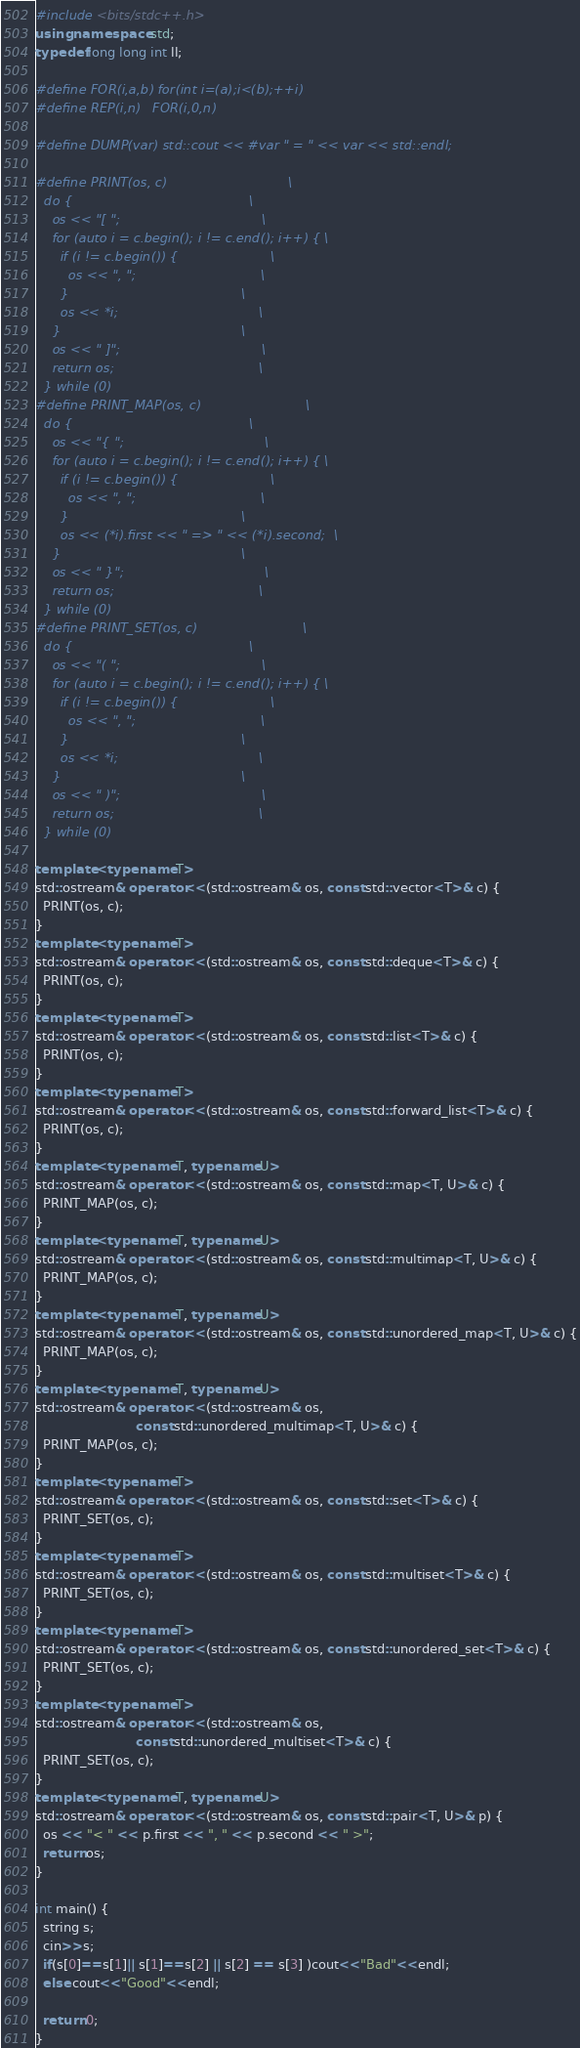Convert code to text. <code><loc_0><loc_0><loc_500><loc_500><_C++_>#include <bits/stdc++.h>
using namespace std;
typedef long long int ll;

#define FOR(i,a,b) for(int i=(a);i<(b);++i)
#define REP(i,n)   FOR(i,0,n)

#define DUMP(var) std::cout << #var " = " << var << std::endl;

#define PRINT(os, c)                              \
  do {                                            \
    os << "[ ";                                   \
    for (auto i = c.begin(); i != c.end(); i++) { \
      if (i != c.begin()) {                       \
        os << ", ";                               \
      }                                           \
      os << *i;                                   \
    }                                             \
    os << " ]";                                   \
    return os;                                    \
  } while (0)
#define PRINT_MAP(os, c)                          \
  do {                                            \
    os << "{ ";                                   \
    for (auto i = c.begin(); i != c.end(); i++) { \
      if (i != c.begin()) {                       \
        os << ", ";                               \
      }                                           \
      os << (*i).first << " => " << (*i).second;  \
    }                                             \
    os << " }";                                   \
    return os;                                    \
  } while (0)
#define PRINT_SET(os, c)                          \
  do {                                            \
    os << "( ";                                   \
    for (auto i = c.begin(); i != c.end(); i++) { \
      if (i != c.begin()) {                       \
        os << ", ";                               \
      }                                           \
      os << *i;                                   \
    }                                             \
    os << " )";                                   \
    return os;                                    \
  } while (0)

template <typename T>
std::ostream& operator<<(std::ostream& os, const std::vector<T>& c) {
  PRINT(os, c);
}
template <typename T>
std::ostream& operator<<(std::ostream& os, const std::deque<T>& c) {
  PRINT(os, c);
}
template <typename T>
std::ostream& operator<<(std::ostream& os, const std::list<T>& c) {
  PRINT(os, c);
}
template <typename T>
std::ostream& operator<<(std::ostream& os, const std::forward_list<T>& c) {
  PRINT(os, c);
}
template <typename T, typename U>
std::ostream& operator<<(std::ostream& os, const std::map<T, U>& c) {
  PRINT_MAP(os, c);
}
template <typename T, typename U>
std::ostream& operator<<(std::ostream& os, const std::multimap<T, U>& c) {
  PRINT_MAP(os, c);
}
template <typename T, typename U>
std::ostream& operator<<(std::ostream& os, const std::unordered_map<T, U>& c) {
  PRINT_MAP(os, c);
}
template <typename T, typename U>
std::ostream& operator<<(std::ostream& os,
                         const std::unordered_multimap<T, U>& c) {
  PRINT_MAP(os, c);
}
template <typename T>
std::ostream& operator<<(std::ostream& os, const std::set<T>& c) {
  PRINT_SET(os, c);
}
template <typename T>
std::ostream& operator<<(std::ostream& os, const std::multiset<T>& c) {
  PRINT_SET(os, c);
}
template <typename T>
std::ostream& operator<<(std::ostream& os, const std::unordered_set<T>& c) {
  PRINT_SET(os, c);
}
template <typename T>
std::ostream& operator<<(std::ostream& os,
                         const std::unordered_multiset<T>& c) {
  PRINT_SET(os, c);
}
template <typename T, typename U>
std::ostream& operator<<(std::ostream& os, const std::pair<T, U>& p) {
  os << "< " << p.first << ", " << p.second << " >";
  return os;
}

int main() {
  string s;
  cin>>s;
  if(s[0]==s[1]|| s[1]==s[2] || s[2] == s[3] )cout<<"Bad"<<endl;
  else cout<<"Good"<<endl;
    
  return 0;
}
</code> 